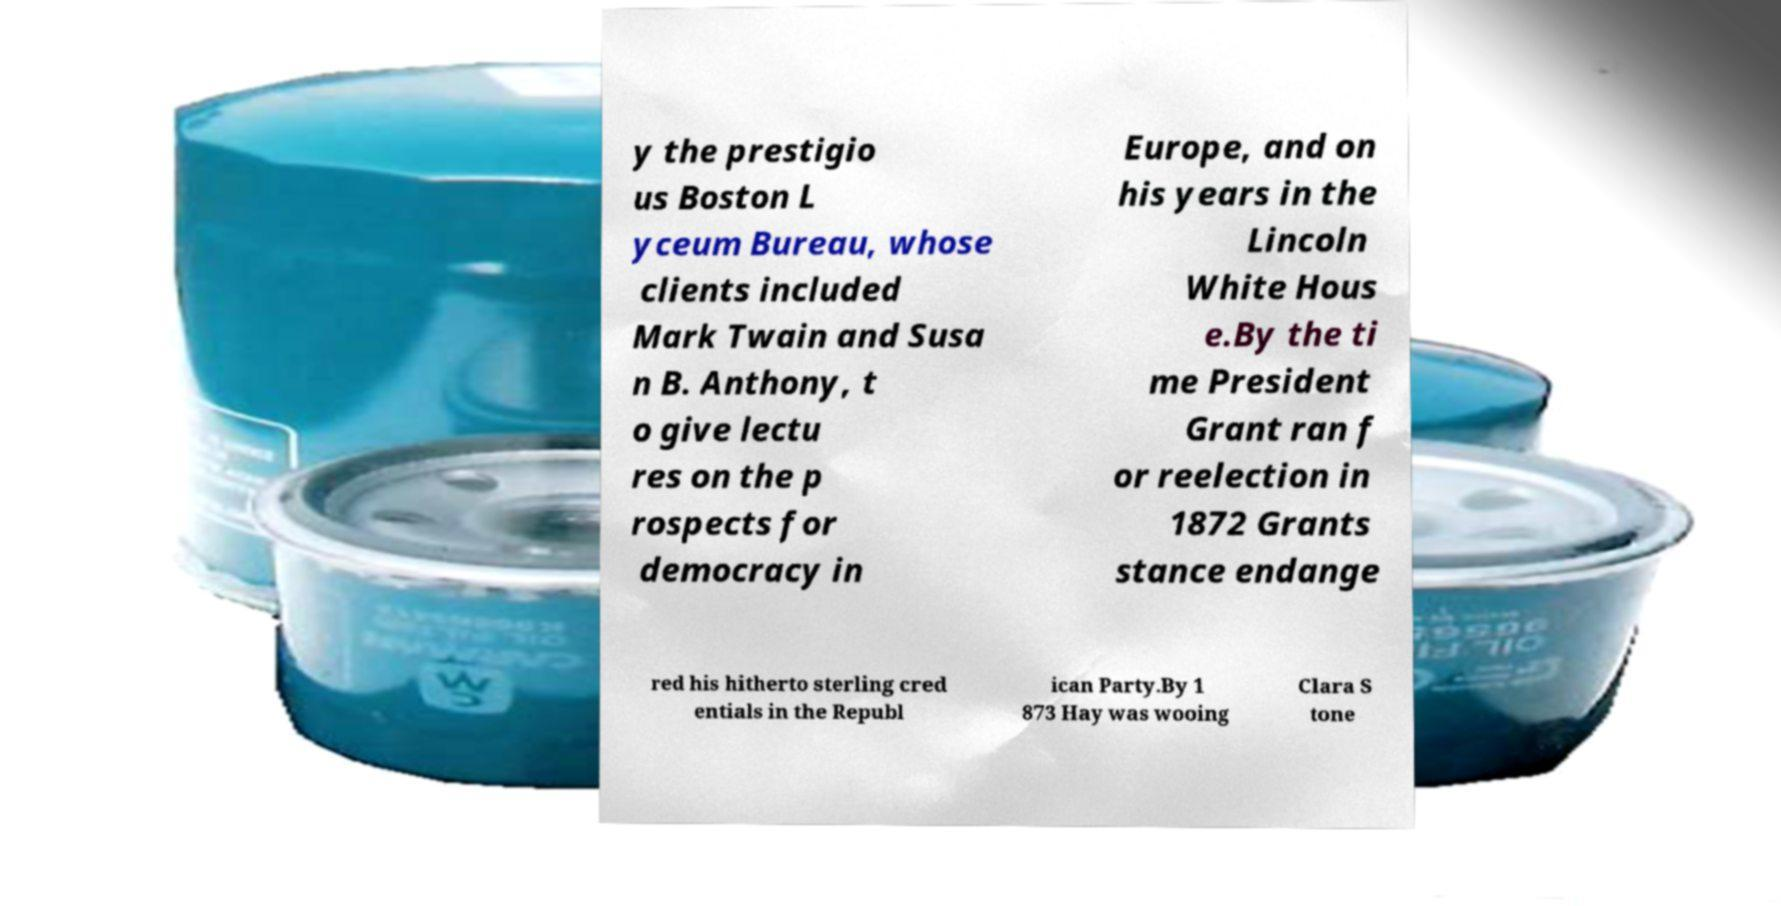Can you accurately transcribe the text from the provided image for me? y the prestigio us Boston L yceum Bureau, whose clients included Mark Twain and Susa n B. Anthony, t o give lectu res on the p rospects for democracy in Europe, and on his years in the Lincoln White Hous e.By the ti me President Grant ran f or reelection in 1872 Grants stance endange red his hitherto sterling cred entials in the Republ ican Party.By 1 873 Hay was wooing Clara S tone 